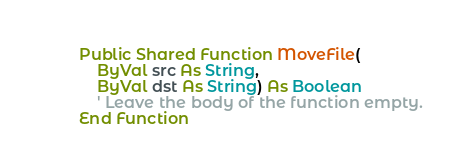<code> <loc_0><loc_0><loc_500><loc_500><_VisualBasic_>        Public Shared Function MoveFile(
            ByVal src As String,
            ByVal dst As String) As Boolean
            ' Leave the body of the function empty.
        End Function</code> 